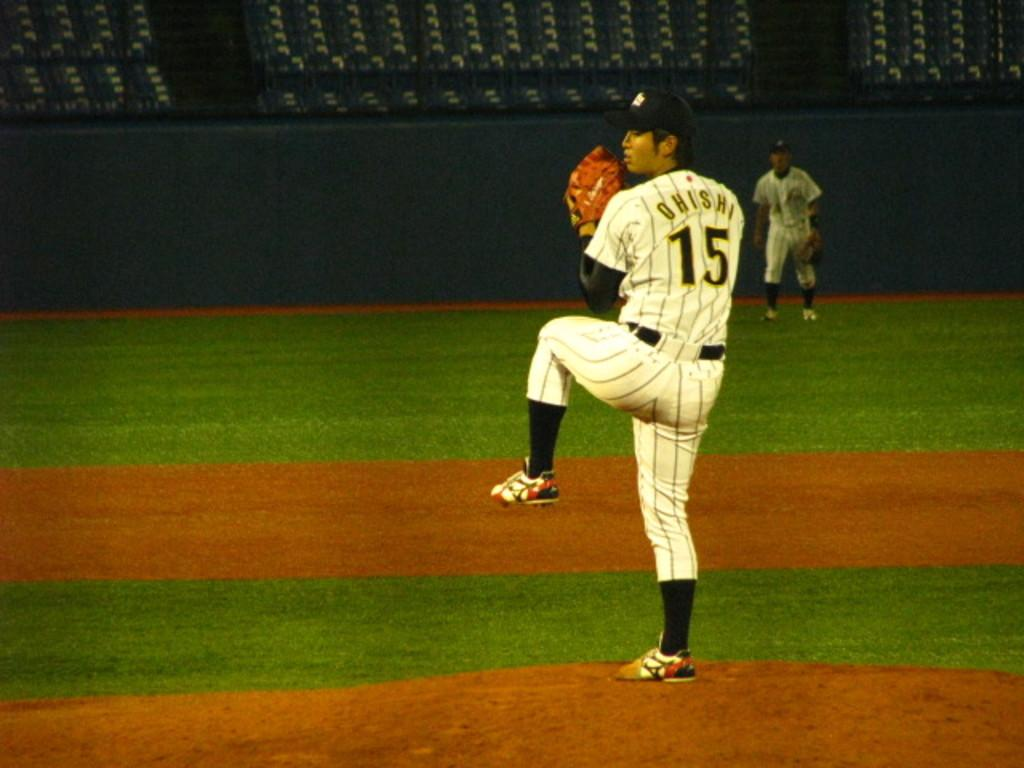Provide a one-sentence caption for the provided image. The player, Ohishi, is pitching at the baseball game. 